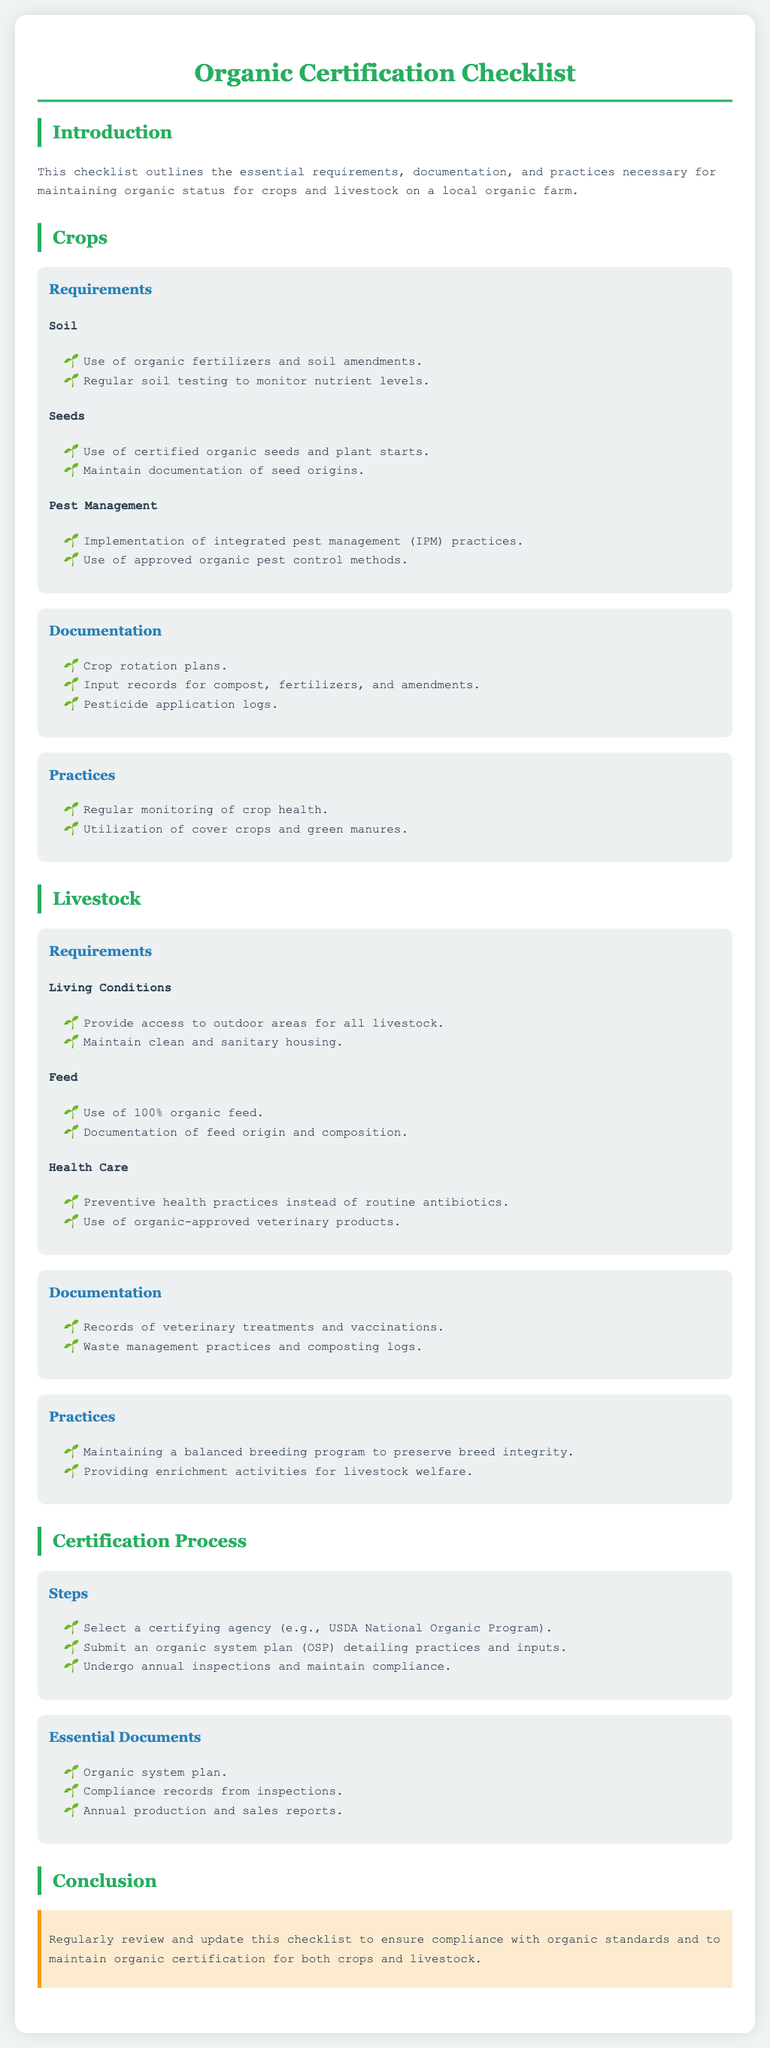What is the first step in the certification process? The first step in the certification process is to select a certifying agency, such as the USDA National Organic Program.
Answer: Select a certifying agency What type of seeds must be used for crops? Crops must utilize certified organic seeds and plant starts.
Answer: Certified organic seeds What records are needed for livestock health care? Records of veterinary treatments and vaccinations are essential for livestock health care documentation.
Answer: Records of veterinary treatments What is one practice to maintain crop health? Regular monitoring of crop health is a vital practice for crops.
Answer: Regular monitoring of crop health How often do farms undergo inspections after certification? Farms must undergo annual inspections to maintain compliance with organic standards.
Answer: Annual inspections What is one requirement for livestock's living conditions? Livestock must have access to outdoor areas as a requirement for their living conditions.
Answer: Access to outdoor areas What type of feed is required for livestock? The livestock must be fed 100 percent organic feed as part of the organic requirements.
Answer: 100% organic feed What documentation is needed for crop pest management? Pesticide application logs are necessary documentation for crop pest management.
Answer: Pesticide application logs What is the organic system plan (OSP)? The organic system plan details the practices and inputs used on the farm.
Answer: A detailed plan of practices and inputs 